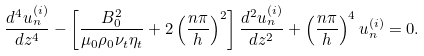Convert formula to latex. <formula><loc_0><loc_0><loc_500><loc_500>\frac { d ^ { 4 } u _ { n } ^ { ( i ) } } { d z ^ { 4 } } - \left [ \frac { B _ { 0 } ^ { 2 } } { \mu _ { 0 } \rho _ { 0 } { \nu _ { t } \eta _ { t } } } + 2 \left ( \frac { n \pi } { h } \right ) ^ { 2 } \right ] \frac { d ^ { 2 } u _ { n } ^ { ( i ) } } { d z ^ { 2 } } + \left ( \frac { n \pi } { h } \right ) ^ { 4 } u _ { n } ^ { ( i ) } = 0 .</formula> 